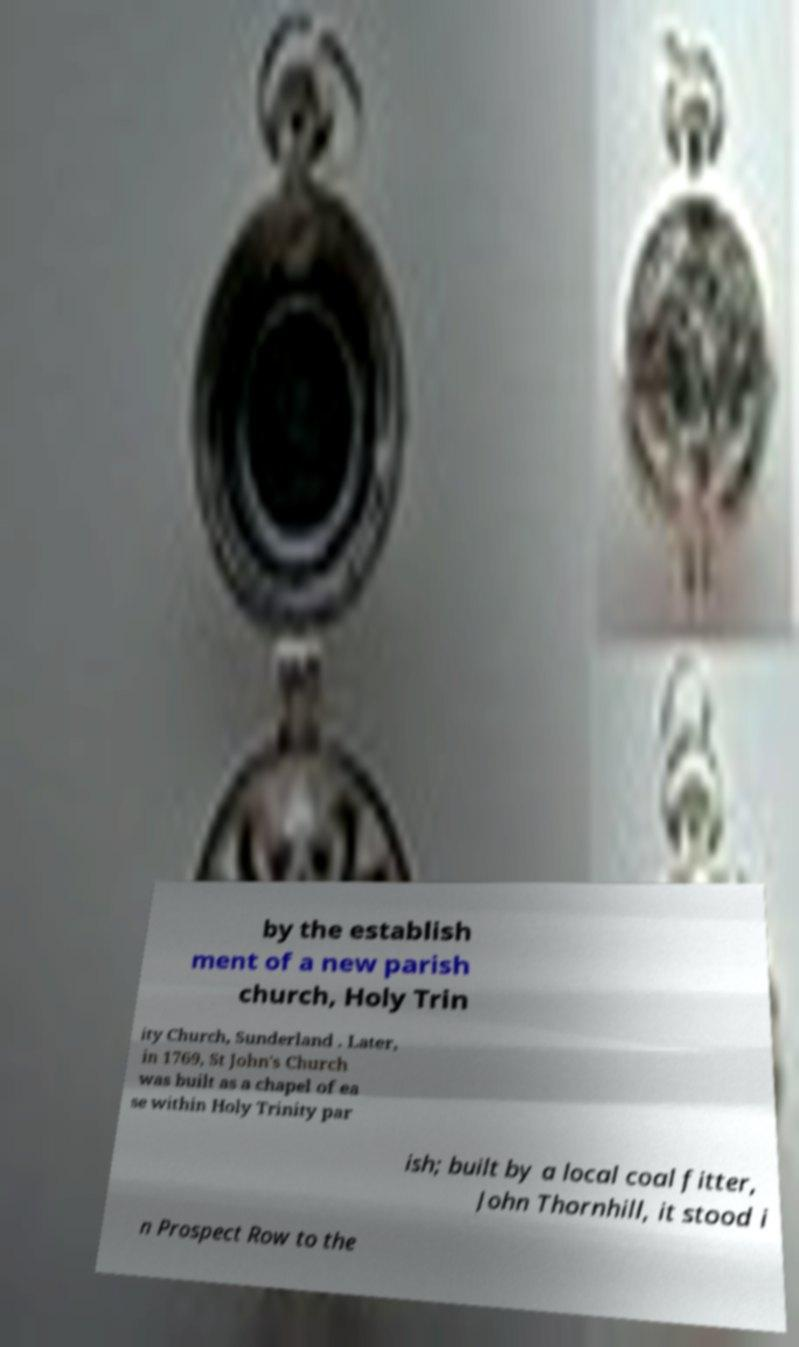Please read and relay the text visible in this image. What does it say? by the establish ment of a new parish church, Holy Trin ity Church, Sunderland . Later, in 1769, St John's Church was built as a chapel of ea se within Holy Trinity par ish; built by a local coal fitter, John Thornhill, it stood i n Prospect Row to the 